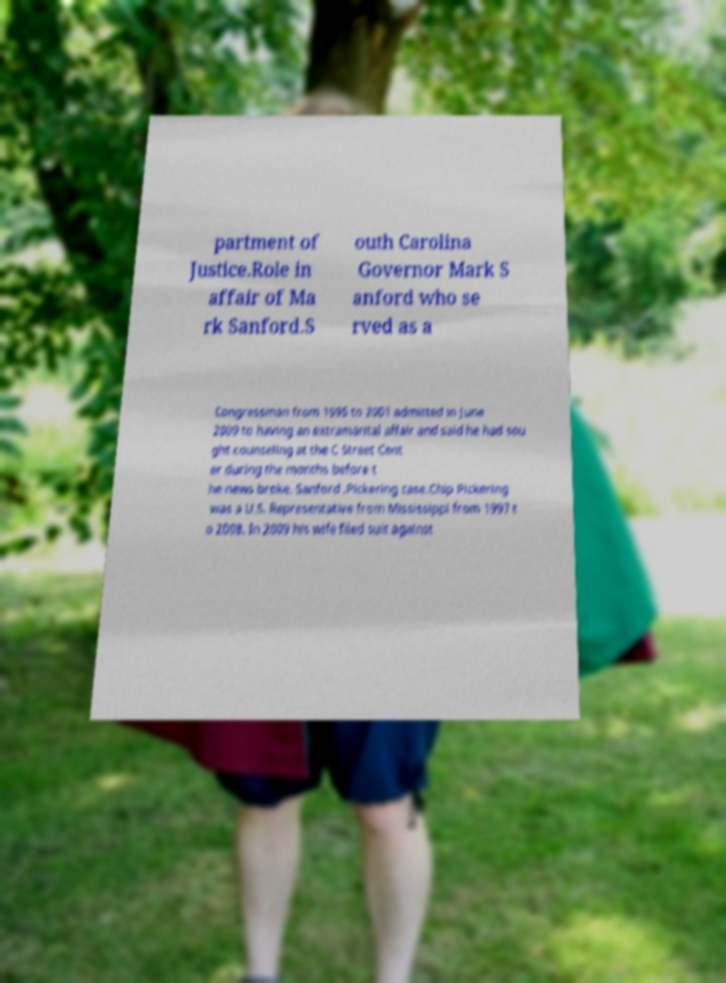Can you read and provide the text displayed in the image?This photo seems to have some interesting text. Can you extract and type it out for me? partment of Justice.Role in affair of Ma rk Sanford.S outh Carolina Governor Mark S anford who se rved as a Congressman from 1995 to 2001 admitted in June 2009 to having an extramarital affair and said he had sou ght counseling at the C Street Cent er during the months before t he news broke. Sanford .Pickering case.Chip Pickering was a U.S. Representative from Mississippi from 1997 t o 2008. In 2009 his wife filed suit against 